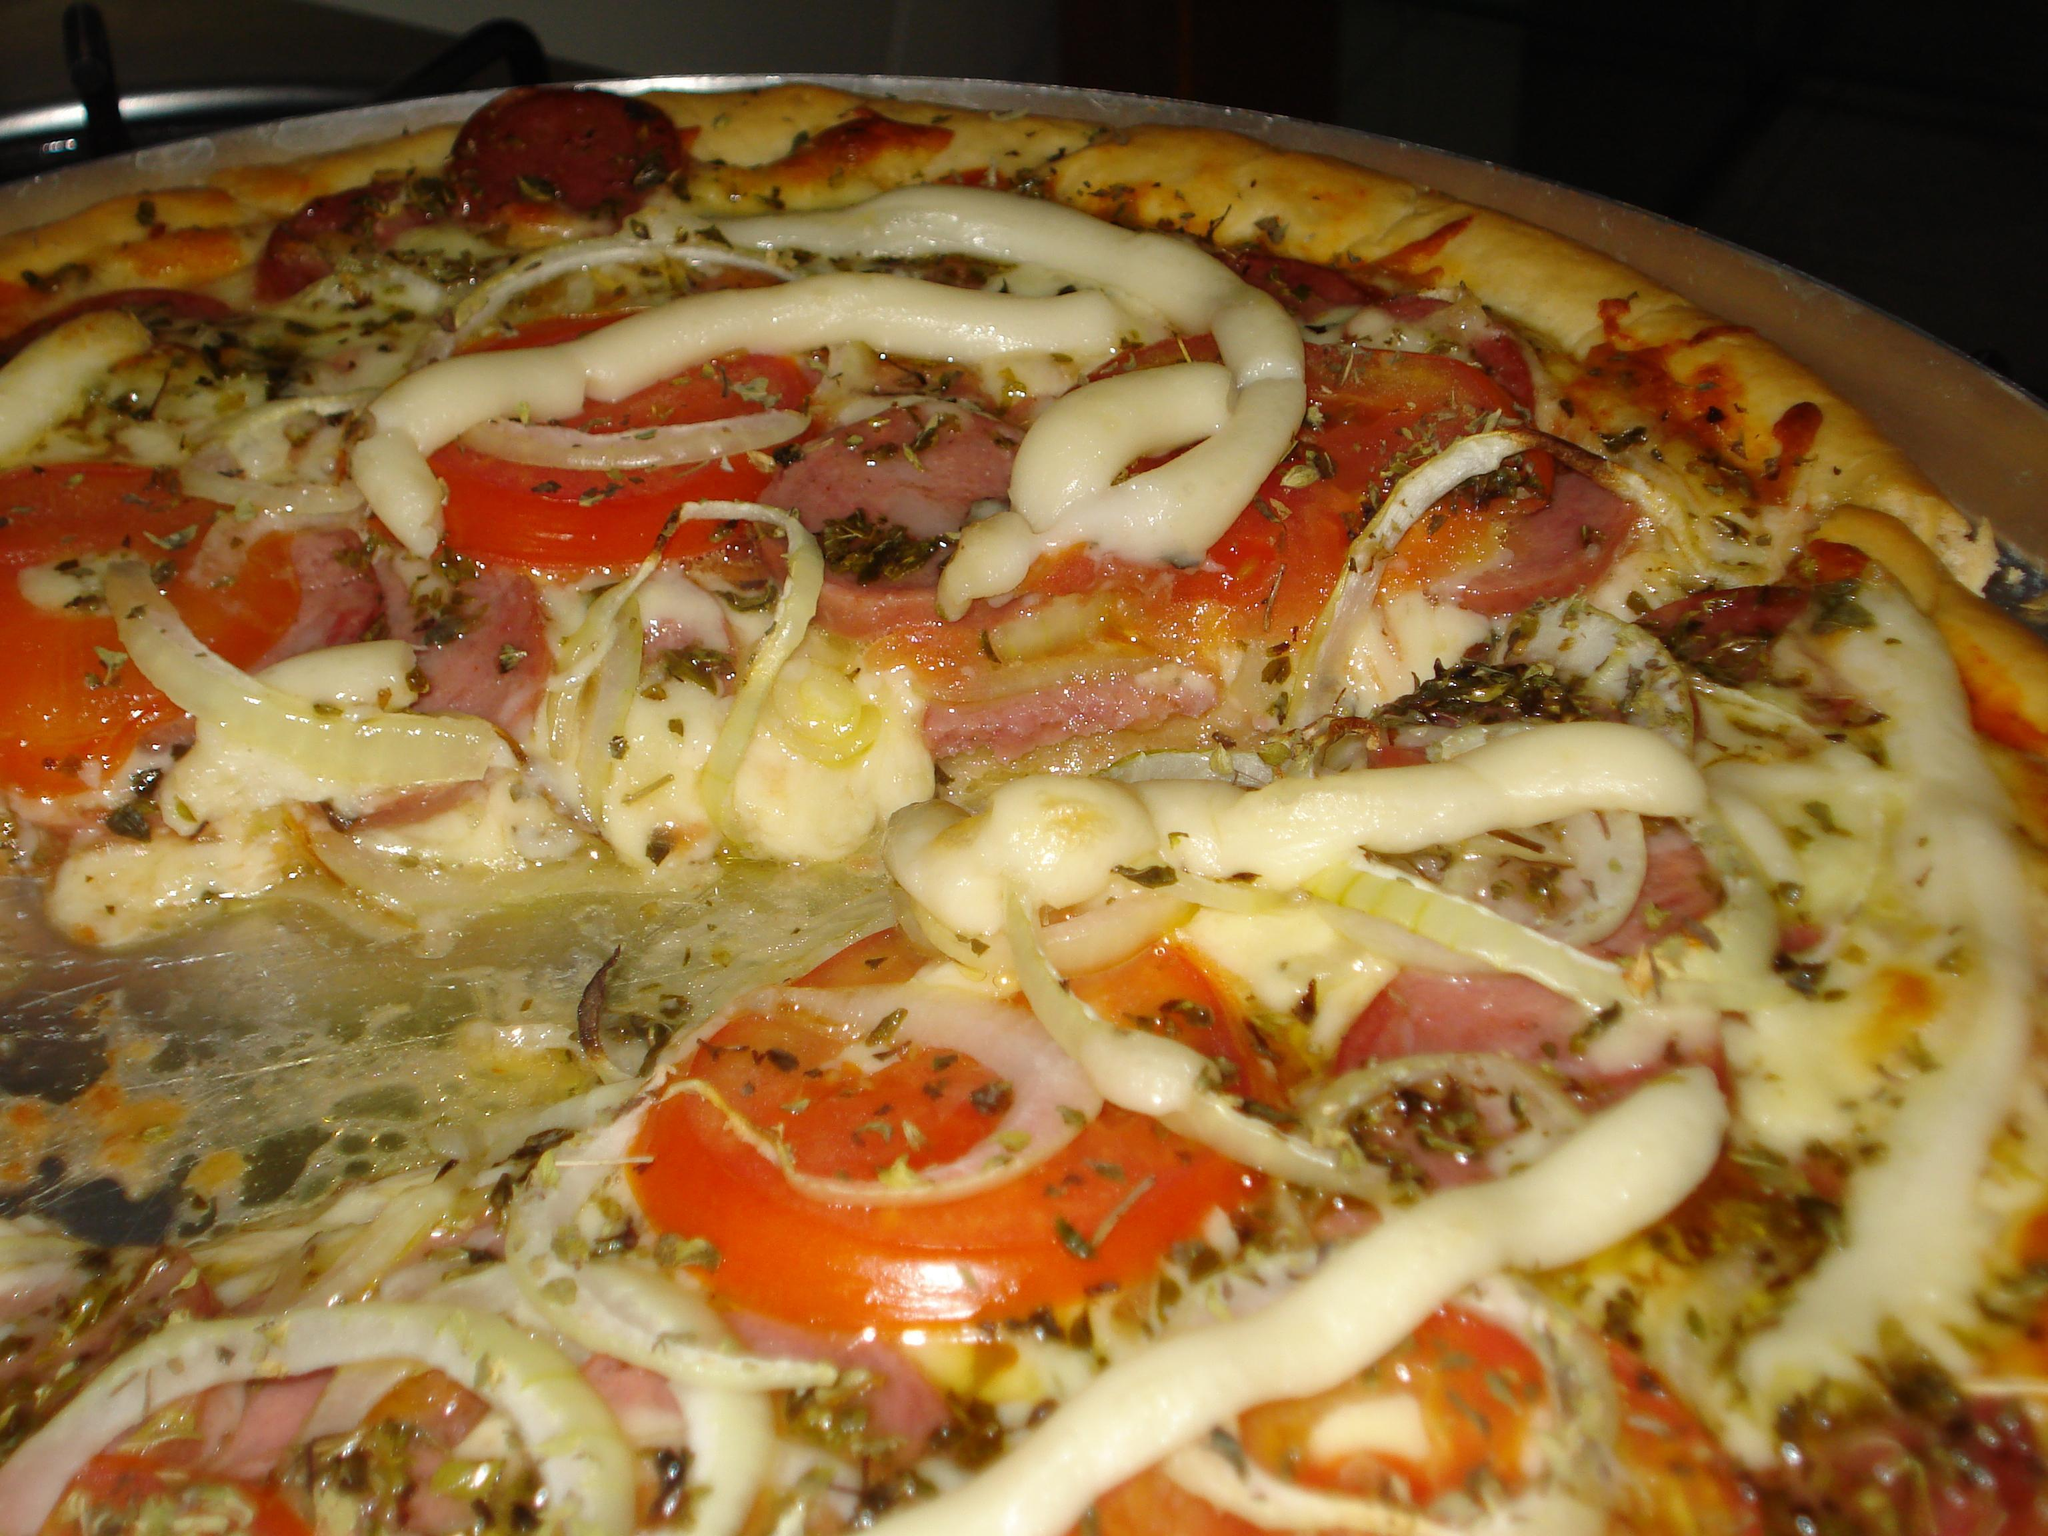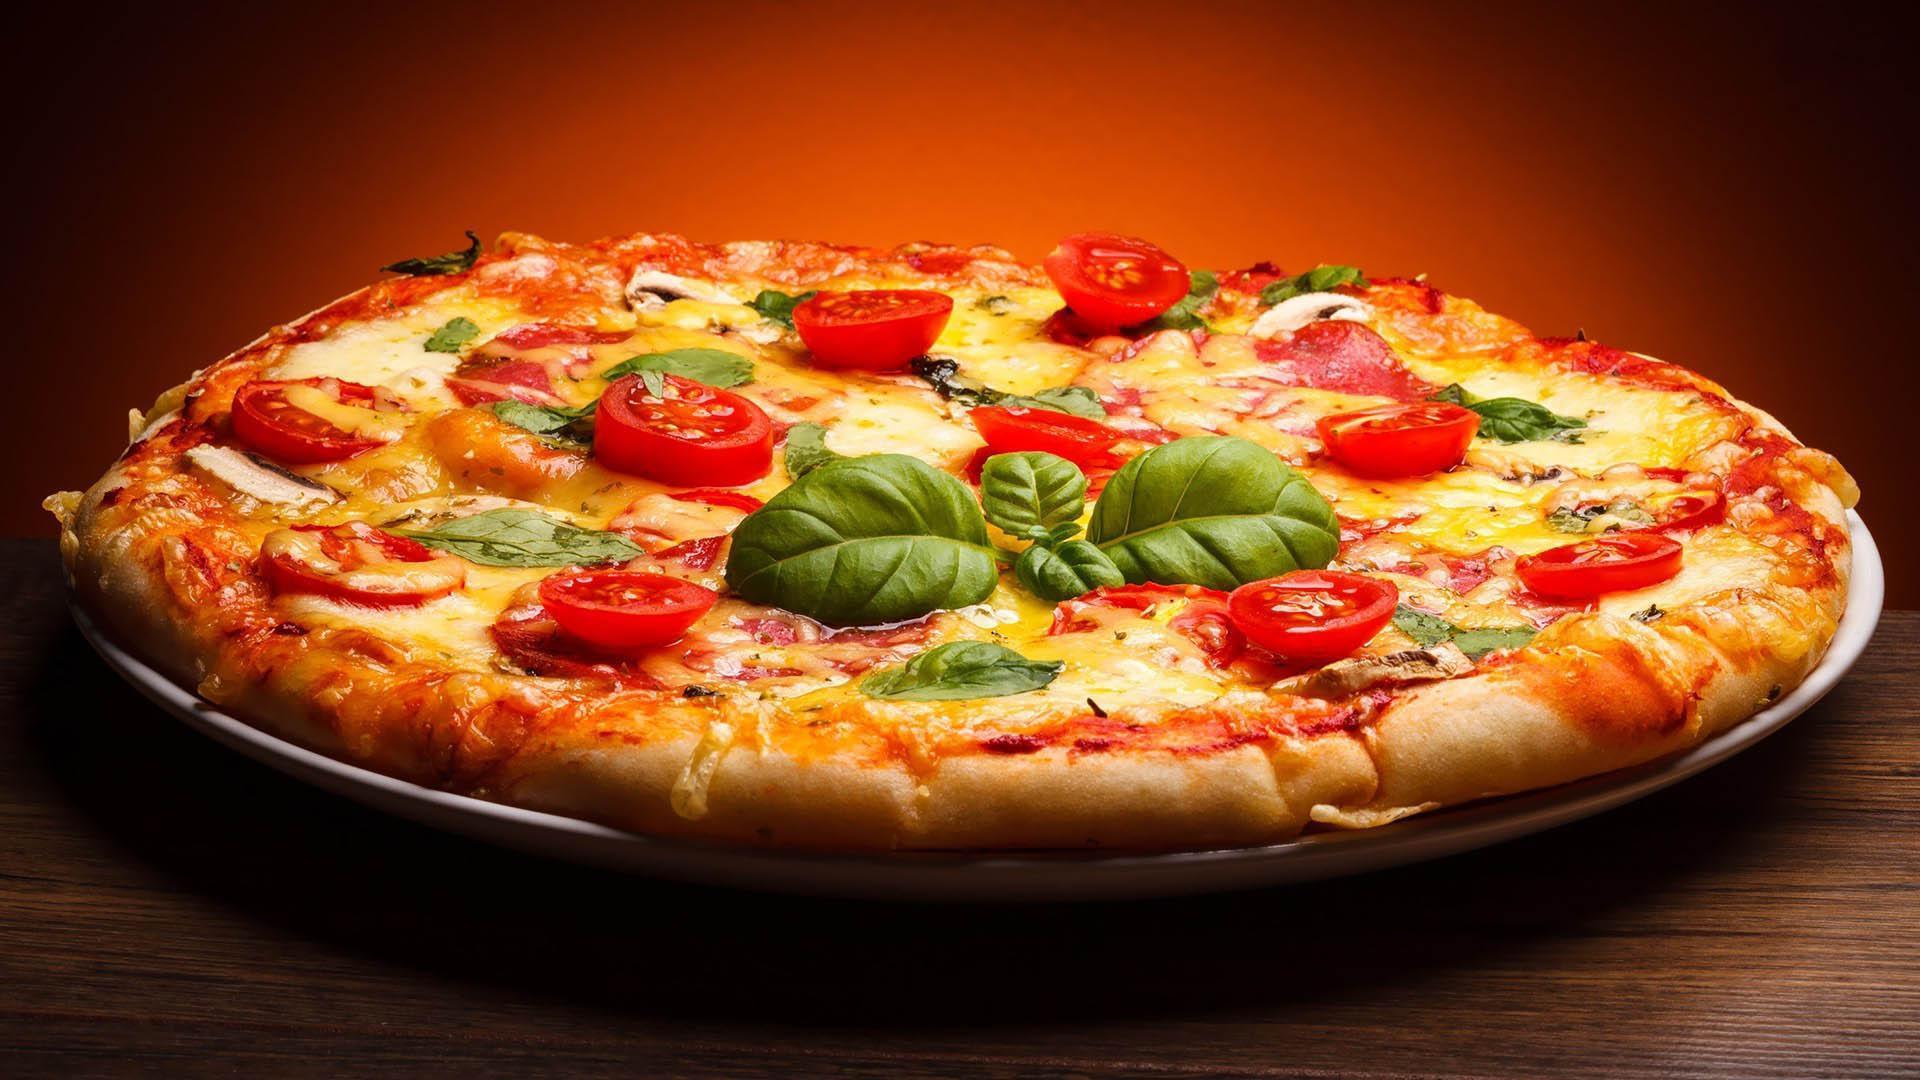The first image is the image on the left, the second image is the image on the right. For the images shown, is this caption "Someone is using a pizza server tool to help themselves to a slice of pizza in at least one of the pictures." true? Answer yes or no. No. The first image is the image on the left, the second image is the image on the right. Examine the images to the left and right. Is the description "An image shows a single slice of pizza lifted upward, with cheese stretching all along the side." accurate? Answer yes or no. No. 